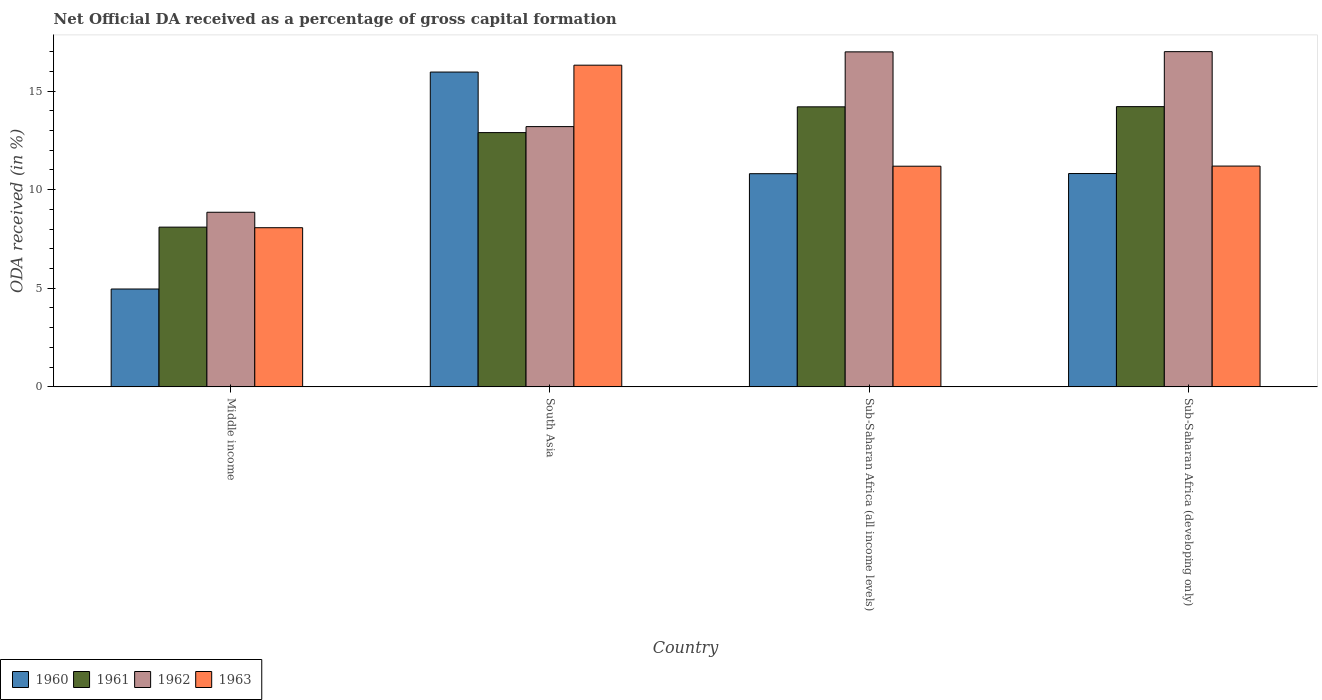How many groups of bars are there?
Offer a terse response. 4. How many bars are there on the 3rd tick from the right?
Keep it short and to the point. 4. What is the label of the 1st group of bars from the left?
Provide a short and direct response. Middle income. What is the net ODA received in 1962 in South Asia?
Ensure brevity in your answer.  13.2. Across all countries, what is the maximum net ODA received in 1960?
Make the answer very short. 15.96. Across all countries, what is the minimum net ODA received in 1963?
Offer a very short reply. 8.07. In which country was the net ODA received in 1960 maximum?
Give a very brief answer. South Asia. What is the total net ODA received in 1962 in the graph?
Offer a very short reply. 56.04. What is the difference between the net ODA received in 1961 in Middle income and that in Sub-Saharan Africa (all income levels)?
Give a very brief answer. -6.1. What is the difference between the net ODA received in 1961 in Sub-Saharan Africa (all income levels) and the net ODA received in 1963 in Sub-Saharan Africa (developing only)?
Make the answer very short. 3. What is the average net ODA received in 1960 per country?
Your answer should be very brief. 10.64. What is the difference between the net ODA received of/in 1961 and net ODA received of/in 1960 in Sub-Saharan Africa (developing only)?
Your response must be concise. 3.39. What is the ratio of the net ODA received in 1963 in Middle income to that in Sub-Saharan Africa (all income levels)?
Your response must be concise. 0.72. Is the net ODA received in 1960 in Sub-Saharan Africa (all income levels) less than that in Sub-Saharan Africa (developing only)?
Make the answer very short. Yes. Is the difference between the net ODA received in 1961 in Middle income and South Asia greater than the difference between the net ODA received in 1960 in Middle income and South Asia?
Your response must be concise. Yes. What is the difference between the highest and the second highest net ODA received in 1960?
Give a very brief answer. 0.01. What is the difference between the highest and the lowest net ODA received in 1960?
Make the answer very short. 11. Is the sum of the net ODA received in 1960 in Middle income and Sub-Saharan Africa (all income levels) greater than the maximum net ODA received in 1963 across all countries?
Give a very brief answer. No. Is it the case that in every country, the sum of the net ODA received in 1963 and net ODA received in 1961 is greater than the sum of net ODA received in 1960 and net ODA received in 1962?
Give a very brief answer. No. What does the 4th bar from the left in Sub-Saharan Africa (all income levels) represents?
Keep it short and to the point. 1963. What does the 4th bar from the right in Middle income represents?
Keep it short and to the point. 1960. Are all the bars in the graph horizontal?
Make the answer very short. No. How many countries are there in the graph?
Ensure brevity in your answer.  4. Does the graph contain any zero values?
Provide a short and direct response. No. Does the graph contain grids?
Offer a terse response. No. How many legend labels are there?
Your answer should be compact. 4. How are the legend labels stacked?
Give a very brief answer. Horizontal. What is the title of the graph?
Your response must be concise. Net Official DA received as a percentage of gross capital formation. What is the label or title of the X-axis?
Ensure brevity in your answer.  Country. What is the label or title of the Y-axis?
Provide a succinct answer. ODA received (in %). What is the ODA received (in %) of 1960 in Middle income?
Your answer should be compact. 4.96. What is the ODA received (in %) in 1961 in Middle income?
Offer a terse response. 8.1. What is the ODA received (in %) in 1962 in Middle income?
Your response must be concise. 8.85. What is the ODA received (in %) in 1963 in Middle income?
Your answer should be very brief. 8.07. What is the ODA received (in %) of 1960 in South Asia?
Offer a very short reply. 15.96. What is the ODA received (in %) of 1961 in South Asia?
Your response must be concise. 12.89. What is the ODA received (in %) in 1962 in South Asia?
Provide a succinct answer. 13.2. What is the ODA received (in %) of 1963 in South Asia?
Keep it short and to the point. 16.31. What is the ODA received (in %) in 1960 in Sub-Saharan Africa (all income levels)?
Your answer should be compact. 10.81. What is the ODA received (in %) in 1961 in Sub-Saharan Africa (all income levels)?
Your answer should be compact. 14.2. What is the ODA received (in %) of 1962 in Sub-Saharan Africa (all income levels)?
Your answer should be compact. 16.99. What is the ODA received (in %) of 1963 in Sub-Saharan Africa (all income levels)?
Ensure brevity in your answer.  11.19. What is the ODA received (in %) of 1960 in Sub-Saharan Africa (developing only)?
Make the answer very short. 10.82. What is the ODA received (in %) of 1961 in Sub-Saharan Africa (developing only)?
Keep it short and to the point. 14.21. What is the ODA received (in %) of 1962 in Sub-Saharan Africa (developing only)?
Your answer should be compact. 17. What is the ODA received (in %) in 1963 in Sub-Saharan Africa (developing only)?
Provide a succinct answer. 11.2. Across all countries, what is the maximum ODA received (in %) of 1960?
Offer a terse response. 15.96. Across all countries, what is the maximum ODA received (in %) in 1961?
Provide a succinct answer. 14.21. Across all countries, what is the maximum ODA received (in %) of 1962?
Provide a succinct answer. 17. Across all countries, what is the maximum ODA received (in %) of 1963?
Give a very brief answer. 16.31. Across all countries, what is the minimum ODA received (in %) of 1960?
Give a very brief answer. 4.96. Across all countries, what is the minimum ODA received (in %) of 1961?
Make the answer very short. 8.1. Across all countries, what is the minimum ODA received (in %) of 1962?
Offer a very short reply. 8.85. Across all countries, what is the minimum ODA received (in %) in 1963?
Provide a succinct answer. 8.07. What is the total ODA received (in %) of 1960 in the graph?
Your response must be concise. 42.55. What is the total ODA received (in %) of 1961 in the graph?
Provide a succinct answer. 49.4. What is the total ODA received (in %) in 1962 in the graph?
Offer a terse response. 56.04. What is the total ODA received (in %) of 1963 in the graph?
Ensure brevity in your answer.  46.77. What is the difference between the ODA received (in %) of 1960 in Middle income and that in South Asia?
Keep it short and to the point. -11. What is the difference between the ODA received (in %) in 1961 in Middle income and that in South Asia?
Make the answer very short. -4.79. What is the difference between the ODA received (in %) in 1962 in Middle income and that in South Asia?
Ensure brevity in your answer.  -4.34. What is the difference between the ODA received (in %) in 1963 in Middle income and that in South Asia?
Offer a terse response. -8.24. What is the difference between the ODA received (in %) of 1960 in Middle income and that in Sub-Saharan Africa (all income levels)?
Offer a terse response. -5.85. What is the difference between the ODA received (in %) in 1961 in Middle income and that in Sub-Saharan Africa (all income levels)?
Provide a short and direct response. -6.1. What is the difference between the ODA received (in %) in 1962 in Middle income and that in Sub-Saharan Africa (all income levels)?
Provide a succinct answer. -8.13. What is the difference between the ODA received (in %) of 1963 in Middle income and that in Sub-Saharan Africa (all income levels)?
Offer a very short reply. -3.12. What is the difference between the ODA received (in %) of 1960 in Middle income and that in Sub-Saharan Africa (developing only)?
Offer a very short reply. -5.85. What is the difference between the ODA received (in %) in 1961 in Middle income and that in Sub-Saharan Africa (developing only)?
Offer a terse response. -6.11. What is the difference between the ODA received (in %) of 1962 in Middle income and that in Sub-Saharan Africa (developing only)?
Provide a succinct answer. -8.14. What is the difference between the ODA received (in %) of 1963 in Middle income and that in Sub-Saharan Africa (developing only)?
Provide a short and direct response. -3.12. What is the difference between the ODA received (in %) of 1960 in South Asia and that in Sub-Saharan Africa (all income levels)?
Give a very brief answer. 5.15. What is the difference between the ODA received (in %) of 1961 in South Asia and that in Sub-Saharan Africa (all income levels)?
Provide a short and direct response. -1.31. What is the difference between the ODA received (in %) in 1962 in South Asia and that in Sub-Saharan Africa (all income levels)?
Provide a succinct answer. -3.79. What is the difference between the ODA received (in %) in 1963 in South Asia and that in Sub-Saharan Africa (all income levels)?
Offer a terse response. 5.12. What is the difference between the ODA received (in %) of 1960 in South Asia and that in Sub-Saharan Africa (developing only)?
Offer a terse response. 5.15. What is the difference between the ODA received (in %) in 1961 in South Asia and that in Sub-Saharan Africa (developing only)?
Keep it short and to the point. -1.32. What is the difference between the ODA received (in %) of 1962 in South Asia and that in Sub-Saharan Africa (developing only)?
Ensure brevity in your answer.  -3.8. What is the difference between the ODA received (in %) in 1963 in South Asia and that in Sub-Saharan Africa (developing only)?
Your response must be concise. 5.12. What is the difference between the ODA received (in %) of 1960 in Sub-Saharan Africa (all income levels) and that in Sub-Saharan Africa (developing only)?
Offer a terse response. -0.01. What is the difference between the ODA received (in %) of 1961 in Sub-Saharan Africa (all income levels) and that in Sub-Saharan Africa (developing only)?
Your answer should be very brief. -0.01. What is the difference between the ODA received (in %) in 1962 in Sub-Saharan Africa (all income levels) and that in Sub-Saharan Africa (developing only)?
Your answer should be compact. -0.01. What is the difference between the ODA received (in %) in 1963 in Sub-Saharan Africa (all income levels) and that in Sub-Saharan Africa (developing only)?
Ensure brevity in your answer.  -0.01. What is the difference between the ODA received (in %) of 1960 in Middle income and the ODA received (in %) of 1961 in South Asia?
Your response must be concise. -7.93. What is the difference between the ODA received (in %) in 1960 in Middle income and the ODA received (in %) in 1962 in South Asia?
Provide a succinct answer. -8.23. What is the difference between the ODA received (in %) in 1960 in Middle income and the ODA received (in %) in 1963 in South Asia?
Ensure brevity in your answer.  -11.35. What is the difference between the ODA received (in %) in 1961 in Middle income and the ODA received (in %) in 1962 in South Asia?
Your answer should be very brief. -5.1. What is the difference between the ODA received (in %) of 1961 in Middle income and the ODA received (in %) of 1963 in South Asia?
Your response must be concise. -8.21. What is the difference between the ODA received (in %) in 1962 in Middle income and the ODA received (in %) in 1963 in South Asia?
Keep it short and to the point. -7.46. What is the difference between the ODA received (in %) of 1960 in Middle income and the ODA received (in %) of 1961 in Sub-Saharan Africa (all income levels)?
Your answer should be very brief. -9.24. What is the difference between the ODA received (in %) of 1960 in Middle income and the ODA received (in %) of 1962 in Sub-Saharan Africa (all income levels)?
Your answer should be compact. -12.02. What is the difference between the ODA received (in %) of 1960 in Middle income and the ODA received (in %) of 1963 in Sub-Saharan Africa (all income levels)?
Your answer should be very brief. -6.23. What is the difference between the ODA received (in %) of 1961 in Middle income and the ODA received (in %) of 1962 in Sub-Saharan Africa (all income levels)?
Offer a terse response. -8.89. What is the difference between the ODA received (in %) of 1961 in Middle income and the ODA received (in %) of 1963 in Sub-Saharan Africa (all income levels)?
Offer a very short reply. -3.09. What is the difference between the ODA received (in %) in 1962 in Middle income and the ODA received (in %) in 1963 in Sub-Saharan Africa (all income levels)?
Your answer should be very brief. -2.33. What is the difference between the ODA received (in %) in 1960 in Middle income and the ODA received (in %) in 1961 in Sub-Saharan Africa (developing only)?
Your answer should be compact. -9.25. What is the difference between the ODA received (in %) in 1960 in Middle income and the ODA received (in %) in 1962 in Sub-Saharan Africa (developing only)?
Your answer should be very brief. -12.04. What is the difference between the ODA received (in %) of 1960 in Middle income and the ODA received (in %) of 1963 in Sub-Saharan Africa (developing only)?
Make the answer very short. -6.23. What is the difference between the ODA received (in %) of 1961 in Middle income and the ODA received (in %) of 1962 in Sub-Saharan Africa (developing only)?
Ensure brevity in your answer.  -8.9. What is the difference between the ODA received (in %) of 1961 in Middle income and the ODA received (in %) of 1963 in Sub-Saharan Africa (developing only)?
Provide a short and direct response. -3.1. What is the difference between the ODA received (in %) of 1962 in Middle income and the ODA received (in %) of 1963 in Sub-Saharan Africa (developing only)?
Offer a terse response. -2.34. What is the difference between the ODA received (in %) of 1960 in South Asia and the ODA received (in %) of 1961 in Sub-Saharan Africa (all income levels)?
Make the answer very short. 1.76. What is the difference between the ODA received (in %) in 1960 in South Asia and the ODA received (in %) in 1962 in Sub-Saharan Africa (all income levels)?
Provide a short and direct response. -1.02. What is the difference between the ODA received (in %) of 1960 in South Asia and the ODA received (in %) of 1963 in Sub-Saharan Africa (all income levels)?
Your answer should be very brief. 4.77. What is the difference between the ODA received (in %) in 1961 in South Asia and the ODA received (in %) in 1962 in Sub-Saharan Africa (all income levels)?
Ensure brevity in your answer.  -4.09. What is the difference between the ODA received (in %) of 1961 in South Asia and the ODA received (in %) of 1963 in Sub-Saharan Africa (all income levels)?
Your response must be concise. 1.7. What is the difference between the ODA received (in %) of 1962 in South Asia and the ODA received (in %) of 1963 in Sub-Saharan Africa (all income levels)?
Give a very brief answer. 2.01. What is the difference between the ODA received (in %) in 1960 in South Asia and the ODA received (in %) in 1961 in Sub-Saharan Africa (developing only)?
Give a very brief answer. 1.75. What is the difference between the ODA received (in %) of 1960 in South Asia and the ODA received (in %) of 1962 in Sub-Saharan Africa (developing only)?
Offer a terse response. -1.03. What is the difference between the ODA received (in %) of 1960 in South Asia and the ODA received (in %) of 1963 in Sub-Saharan Africa (developing only)?
Ensure brevity in your answer.  4.77. What is the difference between the ODA received (in %) in 1961 in South Asia and the ODA received (in %) in 1962 in Sub-Saharan Africa (developing only)?
Give a very brief answer. -4.11. What is the difference between the ODA received (in %) in 1961 in South Asia and the ODA received (in %) in 1963 in Sub-Saharan Africa (developing only)?
Keep it short and to the point. 1.7. What is the difference between the ODA received (in %) of 1962 in South Asia and the ODA received (in %) of 1963 in Sub-Saharan Africa (developing only)?
Make the answer very short. 2. What is the difference between the ODA received (in %) in 1960 in Sub-Saharan Africa (all income levels) and the ODA received (in %) in 1961 in Sub-Saharan Africa (developing only)?
Offer a very short reply. -3.4. What is the difference between the ODA received (in %) in 1960 in Sub-Saharan Africa (all income levels) and the ODA received (in %) in 1962 in Sub-Saharan Africa (developing only)?
Keep it short and to the point. -6.19. What is the difference between the ODA received (in %) in 1960 in Sub-Saharan Africa (all income levels) and the ODA received (in %) in 1963 in Sub-Saharan Africa (developing only)?
Give a very brief answer. -0.39. What is the difference between the ODA received (in %) of 1961 in Sub-Saharan Africa (all income levels) and the ODA received (in %) of 1962 in Sub-Saharan Africa (developing only)?
Make the answer very short. -2.8. What is the difference between the ODA received (in %) in 1961 in Sub-Saharan Africa (all income levels) and the ODA received (in %) in 1963 in Sub-Saharan Africa (developing only)?
Offer a very short reply. 3. What is the difference between the ODA received (in %) in 1962 in Sub-Saharan Africa (all income levels) and the ODA received (in %) in 1963 in Sub-Saharan Africa (developing only)?
Ensure brevity in your answer.  5.79. What is the average ODA received (in %) in 1960 per country?
Give a very brief answer. 10.64. What is the average ODA received (in %) in 1961 per country?
Keep it short and to the point. 12.35. What is the average ODA received (in %) of 1962 per country?
Your answer should be compact. 14.01. What is the average ODA received (in %) of 1963 per country?
Offer a terse response. 11.69. What is the difference between the ODA received (in %) in 1960 and ODA received (in %) in 1961 in Middle income?
Offer a terse response. -3.14. What is the difference between the ODA received (in %) of 1960 and ODA received (in %) of 1962 in Middle income?
Ensure brevity in your answer.  -3.89. What is the difference between the ODA received (in %) in 1960 and ODA received (in %) in 1963 in Middle income?
Keep it short and to the point. -3.11. What is the difference between the ODA received (in %) in 1961 and ODA received (in %) in 1962 in Middle income?
Provide a succinct answer. -0.75. What is the difference between the ODA received (in %) in 1961 and ODA received (in %) in 1963 in Middle income?
Give a very brief answer. 0.03. What is the difference between the ODA received (in %) of 1962 and ODA received (in %) of 1963 in Middle income?
Ensure brevity in your answer.  0.78. What is the difference between the ODA received (in %) in 1960 and ODA received (in %) in 1961 in South Asia?
Your response must be concise. 3.07. What is the difference between the ODA received (in %) of 1960 and ODA received (in %) of 1962 in South Asia?
Offer a terse response. 2.77. What is the difference between the ODA received (in %) in 1960 and ODA received (in %) in 1963 in South Asia?
Give a very brief answer. -0.35. What is the difference between the ODA received (in %) in 1961 and ODA received (in %) in 1962 in South Asia?
Your answer should be compact. -0.3. What is the difference between the ODA received (in %) in 1961 and ODA received (in %) in 1963 in South Asia?
Give a very brief answer. -3.42. What is the difference between the ODA received (in %) of 1962 and ODA received (in %) of 1963 in South Asia?
Your response must be concise. -3.11. What is the difference between the ODA received (in %) in 1960 and ODA received (in %) in 1961 in Sub-Saharan Africa (all income levels)?
Offer a terse response. -3.39. What is the difference between the ODA received (in %) of 1960 and ODA received (in %) of 1962 in Sub-Saharan Africa (all income levels)?
Offer a very short reply. -6.18. What is the difference between the ODA received (in %) in 1960 and ODA received (in %) in 1963 in Sub-Saharan Africa (all income levels)?
Ensure brevity in your answer.  -0.38. What is the difference between the ODA received (in %) of 1961 and ODA received (in %) of 1962 in Sub-Saharan Africa (all income levels)?
Give a very brief answer. -2.79. What is the difference between the ODA received (in %) of 1961 and ODA received (in %) of 1963 in Sub-Saharan Africa (all income levels)?
Offer a very short reply. 3.01. What is the difference between the ODA received (in %) of 1962 and ODA received (in %) of 1963 in Sub-Saharan Africa (all income levels)?
Keep it short and to the point. 5.8. What is the difference between the ODA received (in %) in 1960 and ODA received (in %) in 1961 in Sub-Saharan Africa (developing only)?
Keep it short and to the point. -3.39. What is the difference between the ODA received (in %) in 1960 and ODA received (in %) in 1962 in Sub-Saharan Africa (developing only)?
Offer a terse response. -6.18. What is the difference between the ODA received (in %) of 1960 and ODA received (in %) of 1963 in Sub-Saharan Africa (developing only)?
Ensure brevity in your answer.  -0.38. What is the difference between the ODA received (in %) of 1961 and ODA received (in %) of 1962 in Sub-Saharan Africa (developing only)?
Keep it short and to the point. -2.79. What is the difference between the ODA received (in %) in 1961 and ODA received (in %) in 1963 in Sub-Saharan Africa (developing only)?
Your answer should be very brief. 3.01. What is the difference between the ODA received (in %) in 1962 and ODA received (in %) in 1963 in Sub-Saharan Africa (developing only)?
Provide a succinct answer. 5.8. What is the ratio of the ODA received (in %) of 1960 in Middle income to that in South Asia?
Your response must be concise. 0.31. What is the ratio of the ODA received (in %) of 1961 in Middle income to that in South Asia?
Your answer should be compact. 0.63. What is the ratio of the ODA received (in %) in 1962 in Middle income to that in South Asia?
Your response must be concise. 0.67. What is the ratio of the ODA received (in %) in 1963 in Middle income to that in South Asia?
Make the answer very short. 0.49. What is the ratio of the ODA received (in %) in 1960 in Middle income to that in Sub-Saharan Africa (all income levels)?
Your answer should be very brief. 0.46. What is the ratio of the ODA received (in %) of 1961 in Middle income to that in Sub-Saharan Africa (all income levels)?
Give a very brief answer. 0.57. What is the ratio of the ODA received (in %) in 1962 in Middle income to that in Sub-Saharan Africa (all income levels)?
Offer a very short reply. 0.52. What is the ratio of the ODA received (in %) in 1963 in Middle income to that in Sub-Saharan Africa (all income levels)?
Your answer should be very brief. 0.72. What is the ratio of the ODA received (in %) of 1960 in Middle income to that in Sub-Saharan Africa (developing only)?
Your answer should be very brief. 0.46. What is the ratio of the ODA received (in %) of 1961 in Middle income to that in Sub-Saharan Africa (developing only)?
Ensure brevity in your answer.  0.57. What is the ratio of the ODA received (in %) in 1962 in Middle income to that in Sub-Saharan Africa (developing only)?
Give a very brief answer. 0.52. What is the ratio of the ODA received (in %) in 1963 in Middle income to that in Sub-Saharan Africa (developing only)?
Provide a succinct answer. 0.72. What is the ratio of the ODA received (in %) of 1960 in South Asia to that in Sub-Saharan Africa (all income levels)?
Ensure brevity in your answer.  1.48. What is the ratio of the ODA received (in %) in 1961 in South Asia to that in Sub-Saharan Africa (all income levels)?
Your response must be concise. 0.91. What is the ratio of the ODA received (in %) in 1962 in South Asia to that in Sub-Saharan Africa (all income levels)?
Ensure brevity in your answer.  0.78. What is the ratio of the ODA received (in %) of 1963 in South Asia to that in Sub-Saharan Africa (all income levels)?
Make the answer very short. 1.46. What is the ratio of the ODA received (in %) of 1960 in South Asia to that in Sub-Saharan Africa (developing only)?
Give a very brief answer. 1.48. What is the ratio of the ODA received (in %) in 1961 in South Asia to that in Sub-Saharan Africa (developing only)?
Keep it short and to the point. 0.91. What is the ratio of the ODA received (in %) in 1962 in South Asia to that in Sub-Saharan Africa (developing only)?
Make the answer very short. 0.78. What is the ratio of the ODA received (in %) of 1963 in South Asia to that in Sub-Saharan Africa (developing only)?
Ensure brevity in your answer.  1.46. What is the ratio of the ODA received (in %) of 1960 in Sub-Saharan Africa (all income levels) to that in Sub-Saharan Africa (developing only)?
Give a very brief answer. 1. What is the ratio of the ODA received (in %) in 1961 in Sub-Saharan Africa (all income levels) to that in Sub-Saharan Africa (developing only)?
Your response must be concise. 1. What is the ratio of the ODA received (in %) in 1963 in Sub-Saharan Africa (all income levels) to that in Sub-Saharan Africa (developing only)?
Provide a short and direct response. 1. What is the difference between the highest and the second highest ODA received (in %) in 1960?
Your answer should be very brief. 5.15. What is the difference between the highest and the second highest ODA received (in %) of 1961?
Your response must be concise. 0.01. What is the difference between the highest and the second highest ODA received (in %) of 1962?
Your answer should be very brief. 0.01. What is the difference between the highest and the second highest ODA received (in %) in 1963?
Offer a terse response. 5.12. What is the difference between the highest and the lowest ODA received (in %) in 1960?
Offer a terse response. 11. What is the difference between the highest and the lowest ODA received (in %) of 1961?
Provide a succinct answer. 6.11. What is the difference between the highest and the lowest ODA received (in %) of 1962?
Keep it short and to the point. 8.14. What is the difference between the highest and the lowest ODA received (in %) in 1963?
Ensure brevity in your answer.  8.24. 